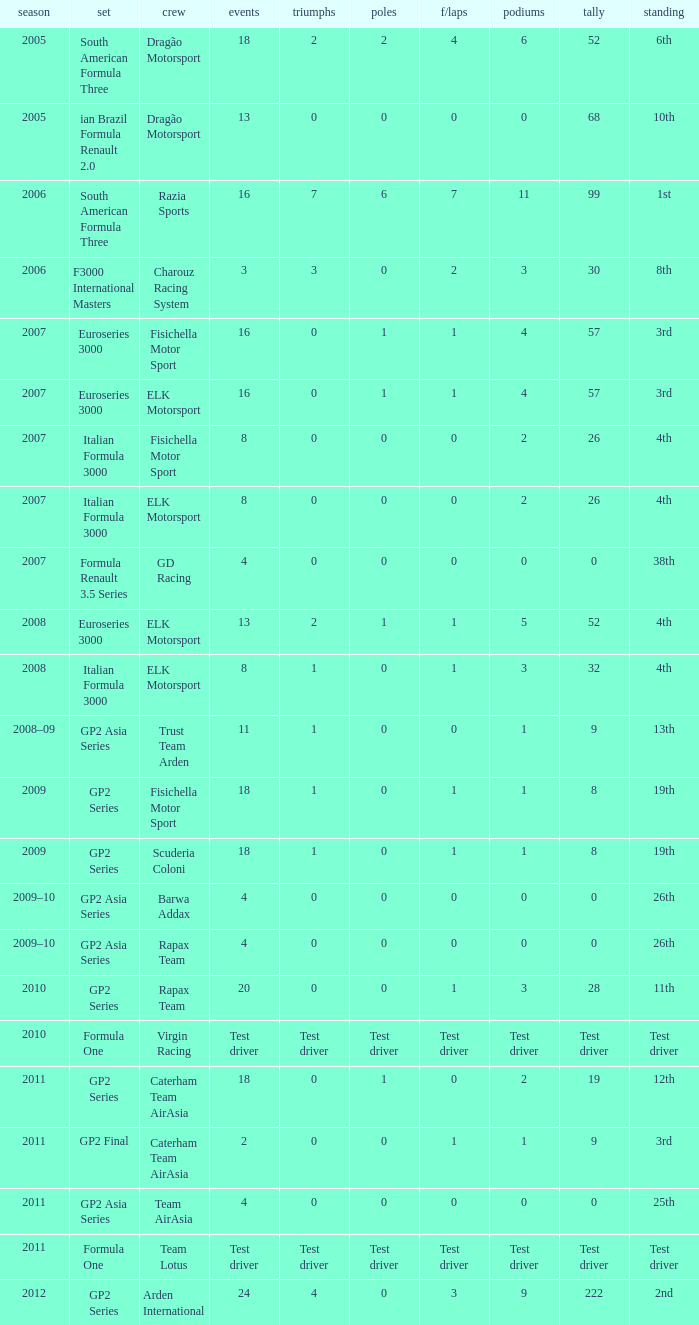What was the F/Laps when the Wins were 0 and the Position was 4th? 0, 0. 